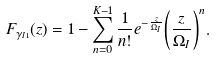<formula> <loc_0><loc_0><loc_500><loc_500>F _ { \gamma _ { I 1 } } ( z ) = 1 - \sum _ { n = 0 } ^ { K - 1 } \frac { 1 } { n ! } e ^ { - \frac { z } { \Omega _ { I } } } { \left ( \frac { z } { \Omega _ { I } } \right ) ^ { n } } .</formula> 